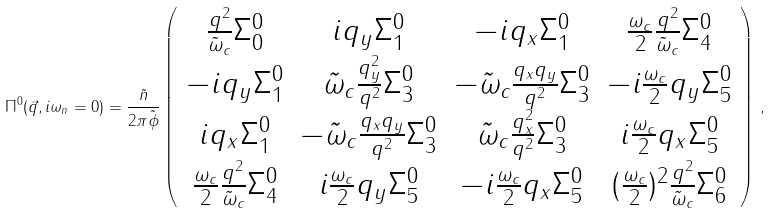<formula> <loc_0><loc_0><loc_500><loc_500>\Pi ^ { 0 } ( \vec { q } , i \omega _ { n } = 0 ) = \frac { \tilde { n } } { 2 \pi \tilde { \phi } } \left ( \begin{array} { c c c c } \frac { q ^ { 2 } } { \tilde { \omega } _ { c } } \Sigma _ { 0 } ^ { 0 } & i q _ { y } \Sigma _ { 1 } ^ { 0 } & - i q _ { x } \Sigma _ { 1 } ^ { 0 } & \frac { \omega _ { c } } { 2 } \frac { q ^ { 2 } } { \tilde { \omega } _ { c } } \Sigma _ { 4 } ^ { 0 } \\ - i q _ { y } \Sigma _ { 1 } ^ { 0 } & \tilde { \omega } _ { c } \frac { q _ { y } ^ { 2 } } { q ^ { 2 } } \Sigma _ { 3 } ^ { 0 } & - \tilde { \omega } _ { c } \frac { q _ { x } q _ { y } } { q ^ { 2 } } \Sigma _ { 3 } ^ { 0 } & - i \frac { \omega _ { c } } { 2 } q _ { y } \Sigma _ { 5 } ^ { 0 } \\ i q _ { x } \Sigma _ { 1 } ^ { 0 } & - \tilde { \omega } _ { c } \frac { q _ { x } q _ { y } } { q ^ { 2 } } \Sigma _ { 3 } ^ { 0 } & \tilde { \omega } _ { c } \frac { q _ { x } ^ { 2 } } { q ^ { 2 } } \Sigma _ { 3 } ^ { 0 } & i \frac { \omega _ { c } } { 2 } q _ { x } \Sigma _ { 5 } ^ { 0 } \\ \frac { \omega _ { c } } { 2 } \frac { q ^ { 2 } } { \tilde { \omega } _ { c } } \Sigma _ { 4 } ^ { 0 } & i \frac { \omega _ { c } } { 2 } q _ { y } \Sigma _ { 5 } ^ { 0 } & - i \frac { \omega _ { c } } { 2 } q _ { x } \Sigma _ { 5 } ^ { 0 } & ( \frac { \omega _ { c } } { 2 } ) ^ { 2 } \frac { q ^ { 2 } } { \tilde { \omega } _ { c } } \Sigma _ { 6 } ^ { 0 } \end{array} \right ) \, ,</formula> 